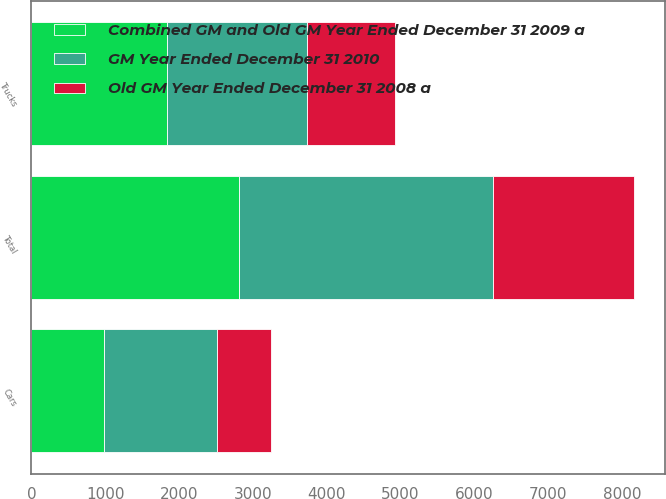<chart> <loc_0><loc_0><loc_500><loc_500><stacked_bar_chart><ecel><fcel>Cars<fcel>Trucks<fcel>Total<nl><fcel>Combined GM and Old GM Year Ended December 31 2009 a<fcel>977<fcel>1832<fcel>2809<nl><fcel>Old GM Year Ended December 31 2008 a<fcel>727<fcel>1186<fcel>1913<nl><fcel>GM Year Ended December 31 2010<fcel>1543<fcel>1906<fcel>3449<nl></chart> 